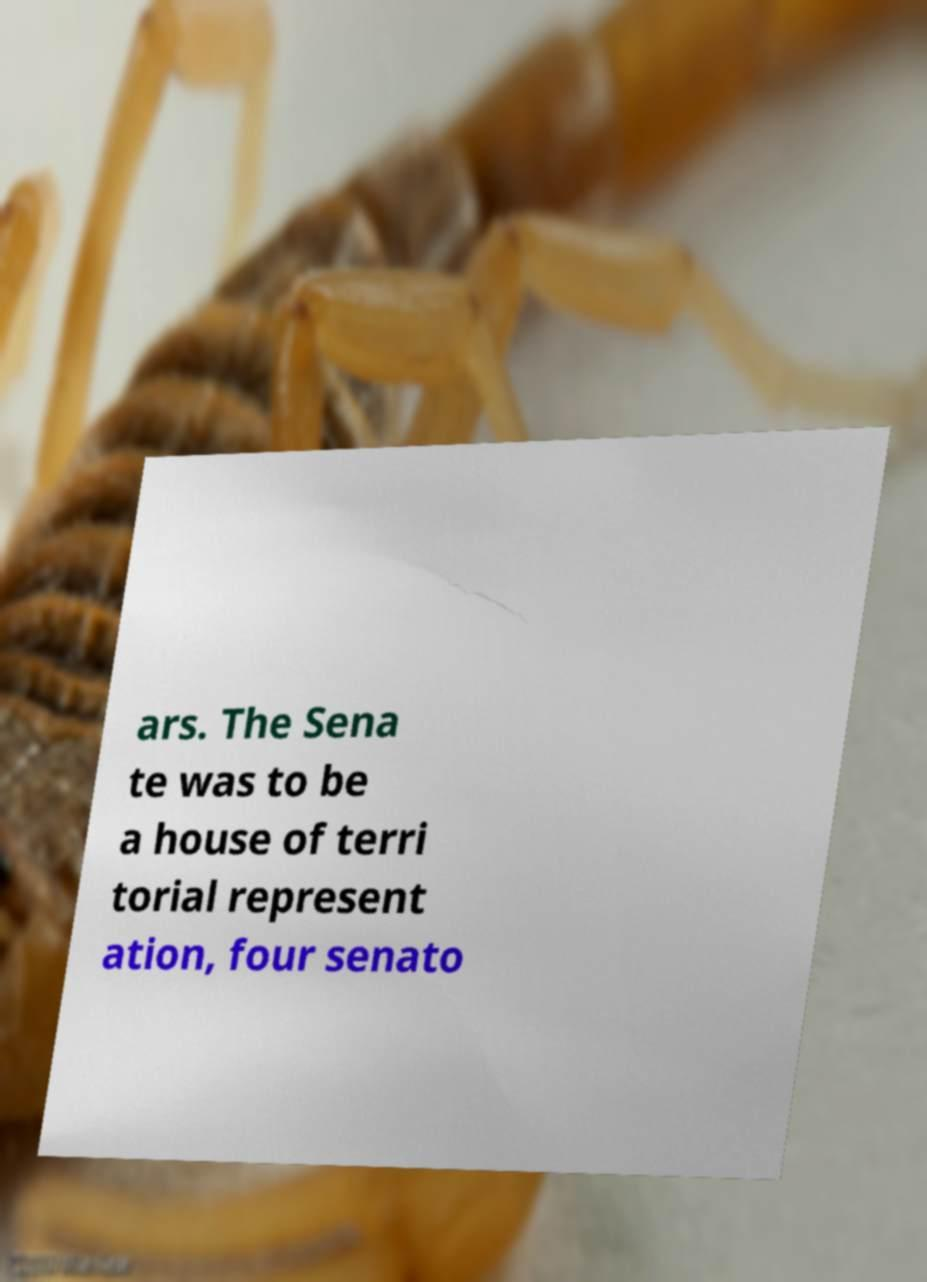Please identify and transcribe the text found in this image. ars. The Sena te was to be a house of terri torial represent ation, four senato 